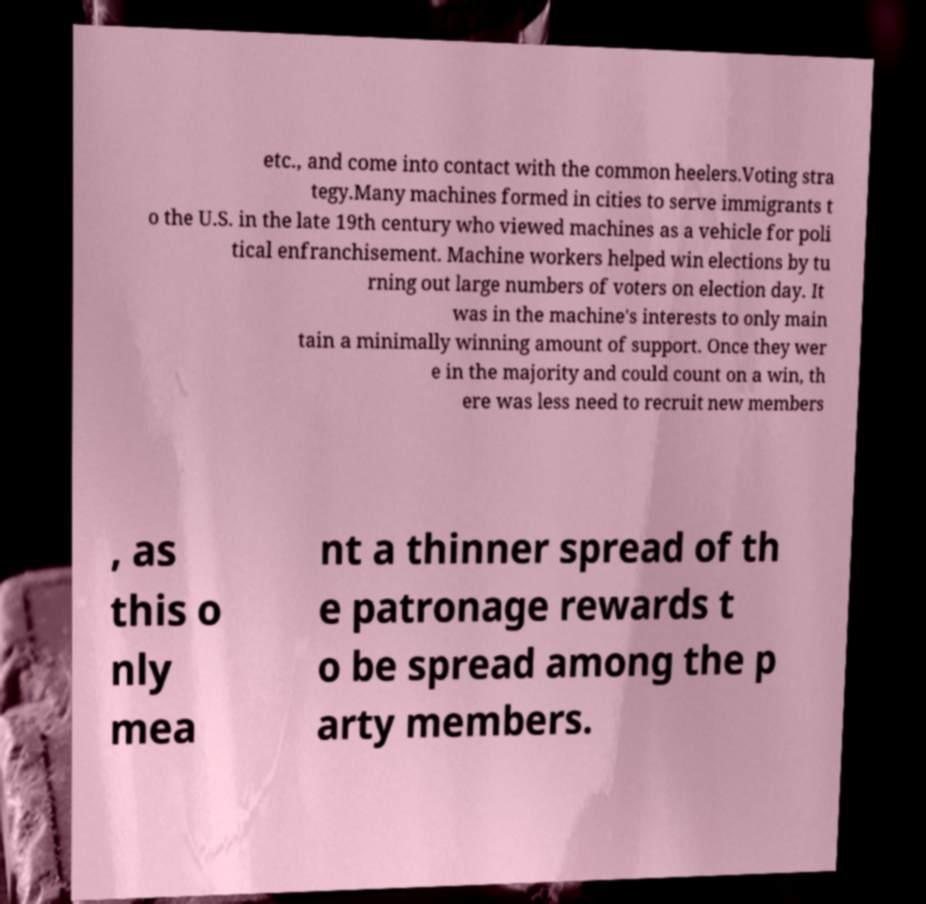I need the written content from this picture converted into text. Can you do that? etc., and come into contact with the common heelers.Voting stra tegy.Many machines formed in cities to serve immigrants t o the U.S. in the late 19th century who viewed machines as a vehicle for poli tical enfranchisement. Machine workers helped win elections by tu rning out large numbers of voters on election day. It was in the machine's interests to only main tain a minimally winning amount of support. Once they wer e in the majority and could count on a win, th ere was less need to recruit new members , as this o nly mea nt a thinner spread of th e patronage rewards t o be spread among the p arty members. 